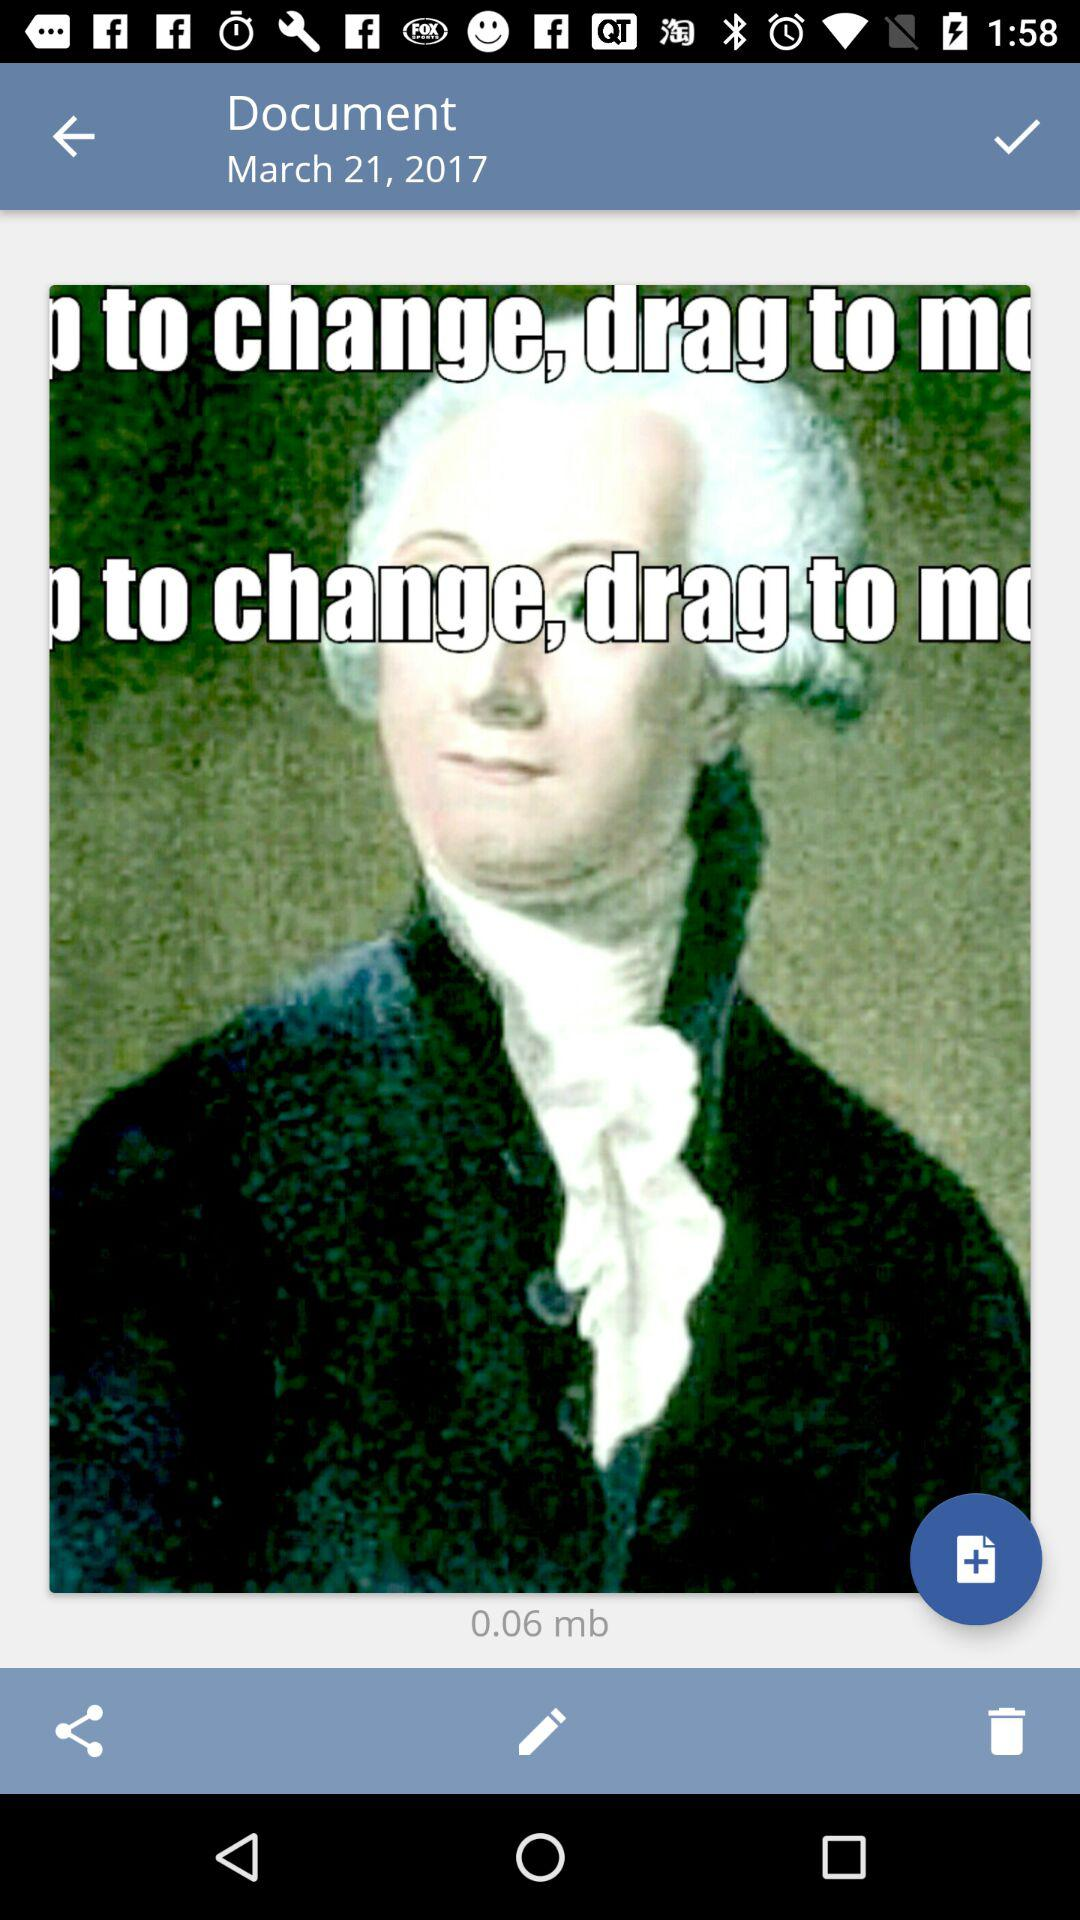How much is the document size?
Answer the question using a single word or phrase. 0.06 mb 